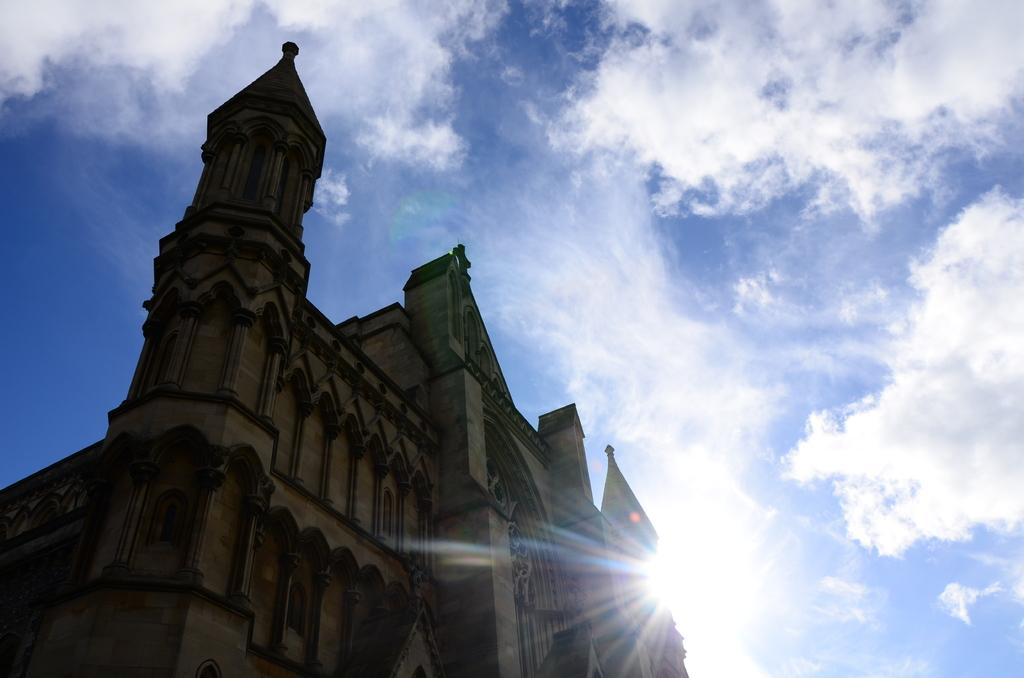What is the main structure in the front of the image? There is a building in the front of the image. What can be seen in the background of the image? The sky is cloudy in the background, and sunlight is visible. How many cans are visible in the image? There are no cans present in the image. What type of deer can be seen in the image? There are no deer present in the image. 